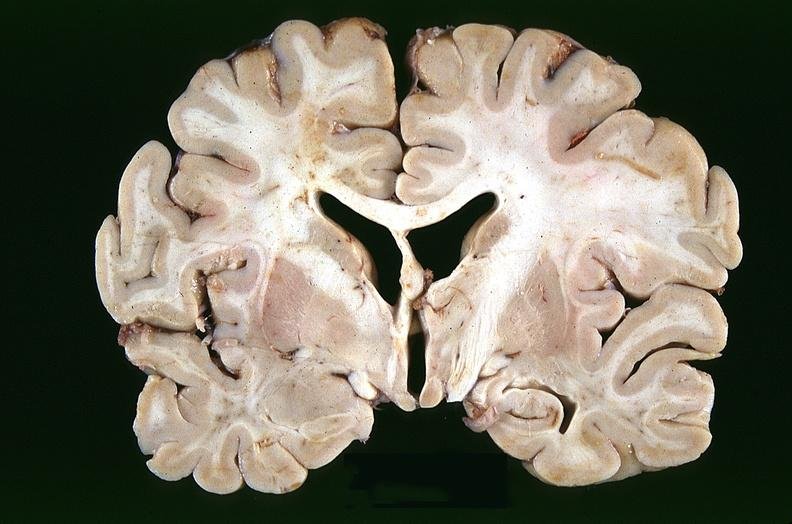what does this image show?
Answer the question using a single word or phrase. Brain 